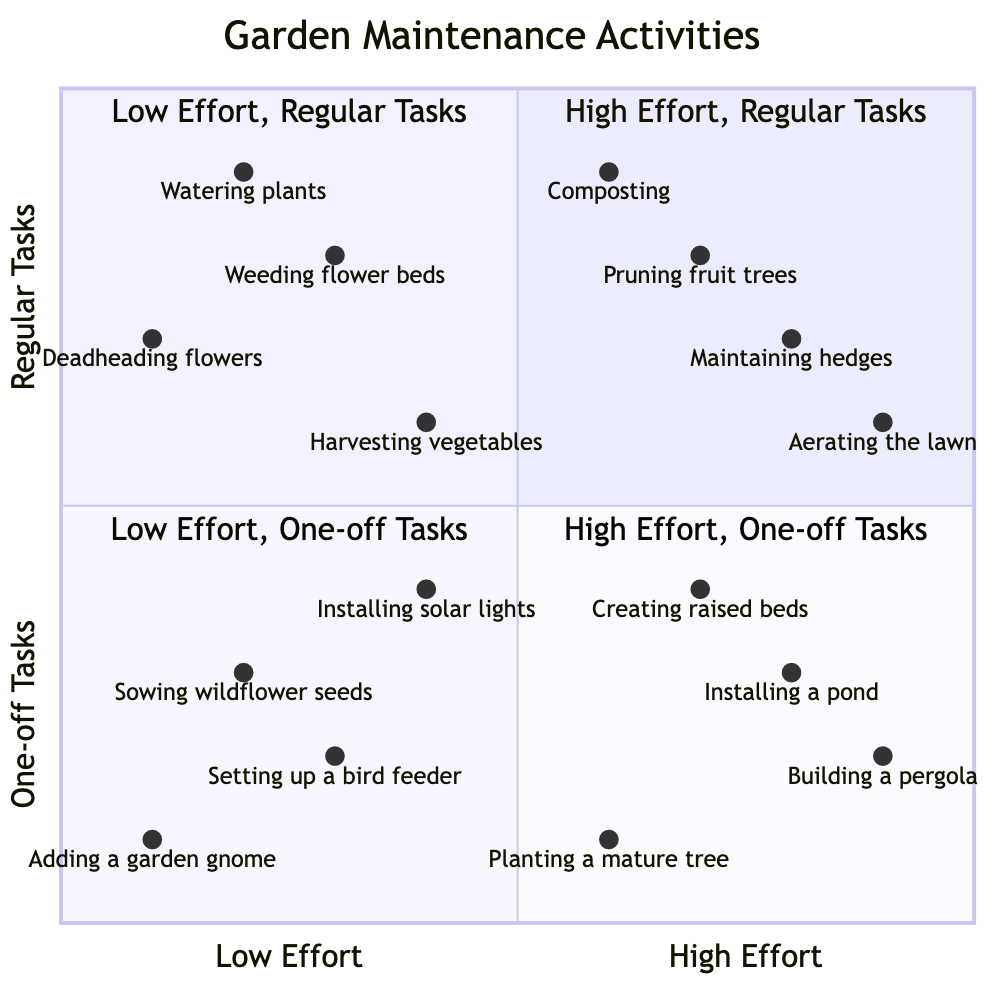What activities are classified as high effort, one-off tasks? The diagram specifies the activities located in the "High Effort - One-off Tasks" quadrant, which includes "Building a garden pergola," "Installing a pond," "Creating raised garden beds," and "Planting a mature tree." Each of these tasks is placed in this quadrant, confirming their classification.
Answer: Building a garden pergola, Installing a pond, Creating raised garden beds, Planting a mature tree How many activities are considered low effort, regular tasks? To find the number of activities in the "Low Effort - Regular Tasks" quadrant, we check the listed items: "Watering plants," "Weeding flower beds," "Deadheading flowers," and "Harvesting vegetables." Counting these gives a total of four activities.
Answer: 4 Which activity falls under high effort and regular tasks? The question targets the "High Effort - Regular Tasks" quadrant. The activities listed within that quadrant are "Pruning fruit trees," "Maintaining hedges," "Aerating the lawn," and "Composting." One such activity can be chosen as an example.
Answer: Pruning fruit trees What is the most effort-consuming regular task based on this diagram? Investigating the "High Effort - Regular Tasks" section, we identify each task's placement in relation to effort level. "Aerating the lawn" is positioned the highest in the effort scale within this quadrant, making it the task that requires the most effort among regular activities.
Answer: Aerating the lawn Which low effort, one-off task is nearest to the origin? The origin of the diagram is the point representing (0,0). We need to identify the activities in the "Low Effort - One-off Tasks" quadrant. Among "Setting up a bird feeder," "Sowing wildflower seeds," "Adding a garden gnome," and "Installing solar garden lights," "Adding a garden gnome" is the closest as it has the least coordinates (0.1, 0.1).
Answer: Adding a garden gnome 